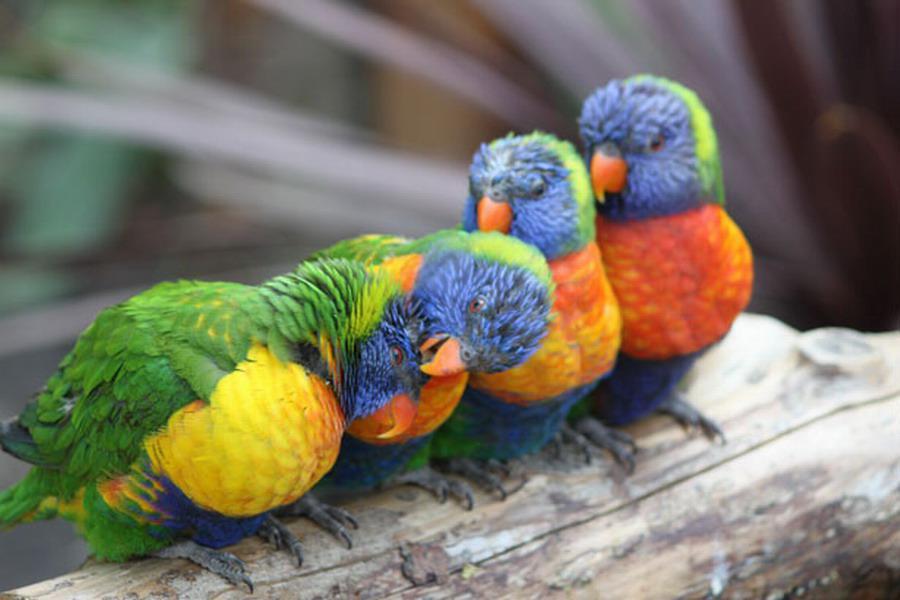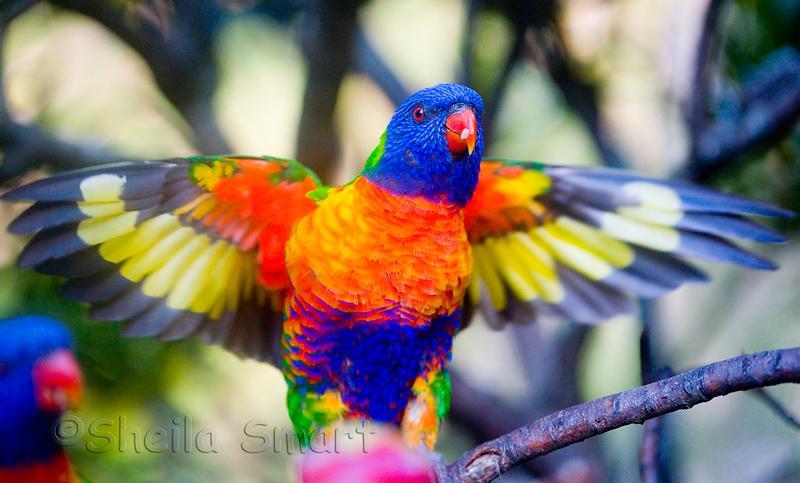The first image is the image on the left, the second image is the image on the right. Given the left and right images, does the statement "Only parrots in flight are shown in the images." hold true? Answer yes or no. No. The first image is the image on the left, the second image is the image on the right. Given the left and right images, does the statement "Both images show a parrot that is flying" hold true? Answer yes or no. No. 